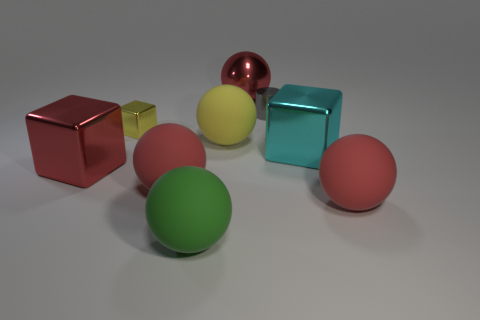Subtract all large metal cubes. How many cubes are left? 1 Subtract all red cylinders. How many red spheres are left? 3 Add 1 tiny objects. How many objects exist? 10 Subtract all green balls. How many balls are left? 4 Subtract all cylinders. How many objects are left? 8 Subtract 1 blocks. How many blocks are left? 2 Subtract all large yellow things. Subtract all small cylinders. How many objects are left? 7 Add 5 red metallic spheres. How many red metallic spheres are left? 6 Add 7 tiny cyan things. How many tiny cyan things exist? 7 Subtract 1 green balls. How many objects are left? 8 